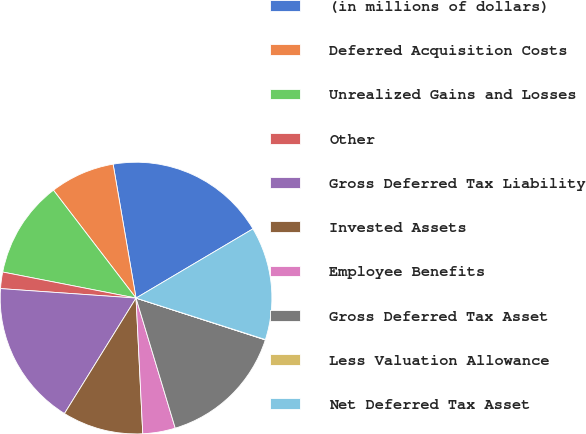Convert chart to OTSL. <chart><loc_0><loc_0><loc_500><loc_500><pie_chart><fcel>(in millions of dollars)<fcel>Deferred Acquisition Costs<fcel>Unrealized Gains and Losses<fcel>Other<fcel>Gross Deferred Tax Liability<fcel>Invested Assets<fcel>Employee Benefits<fcel>Gross Deferred Tax Asset<fcel>Less Valuation Allowance<fcel>Net Deferred Tax Asset<nl><fcel>19.19%<fcel>7.7%<fcel>11.53%<fcel>1.96%<fcel>17.28%<fcel>9.62%<fcel>3.87%<fcel>15.36%<fcel>0.04%<fcel>13.45%<nl></chart> 